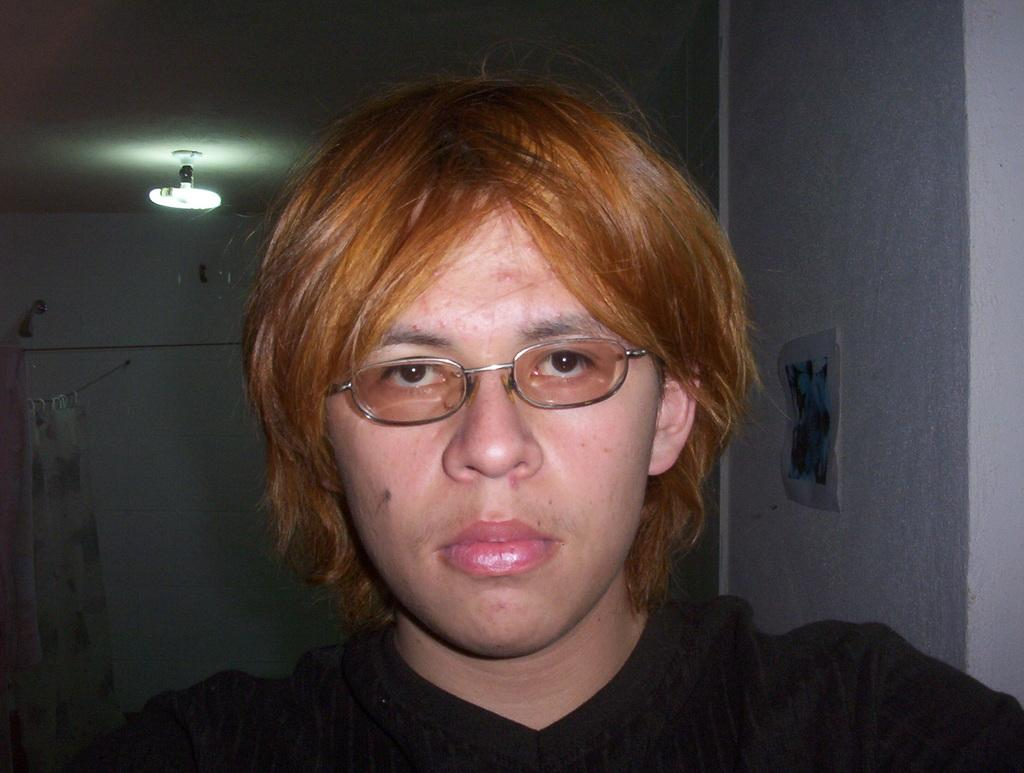What is present in the image? There is a person in the image. Can you describe the person's appearance? The person is wearing spectacles and a black dress. What can be seen in the background of the image? There is a light and a curtain in the background of the image. Reasoning: Let'ing: Let's think step by step in order to produce the conversation. We start by identifying the main subject in the image, which is the person. Then, we expand the conversation to include details about the person's appearance, such as their spectacles and black dress. Finally, we describe the background of the image, mentioning the light and curtain. Absurd Question/Answer: What type of sweater is the person wearing in the image? The person is not wearing a sweater in the image; they are wearing a black dress. Can you describe the grass in the image? There is no grass present in the image. What type of sweater is the person wearing in the image? The person is not wearing a sweater in the image; they are wearing a black dress. Can you describe the grass in the image? There is no grass present in the image. 